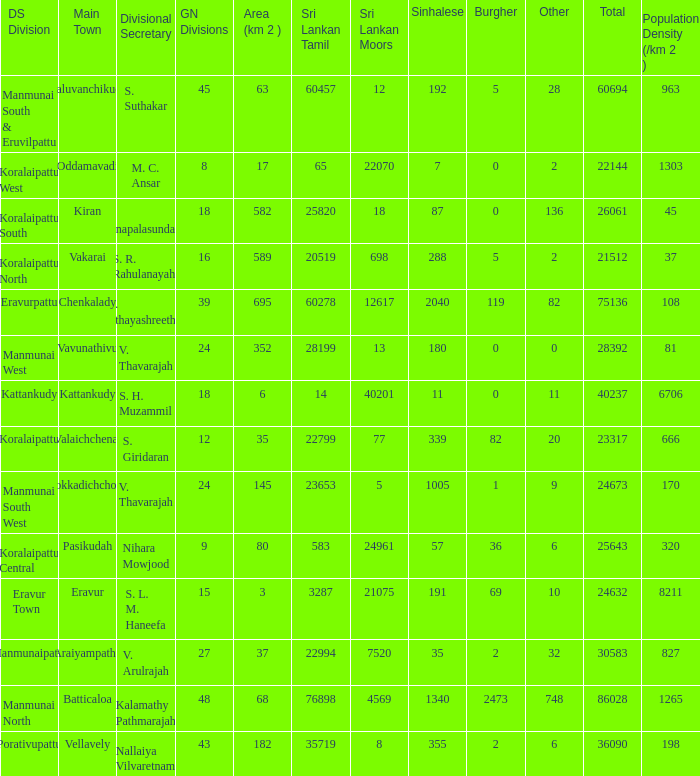What is the name of the DS division where the divisional secretary is S. H. Muzammil? Kattankudy. 